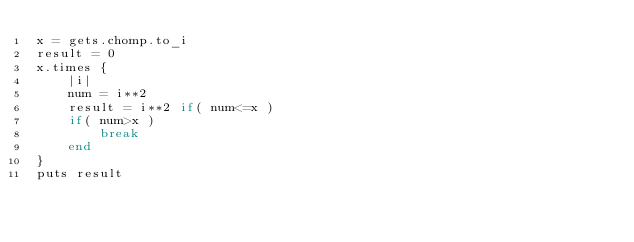<code> <loc_0><loc_0><loc_500><loc_500><_Ruby_>x = gets.chomp.to_i
result = 0
x.times {
    |i|
    num = i**2
    result = i**2 if( num<=x )
    if( num>x )
        break
    end
}
puts result</code> 